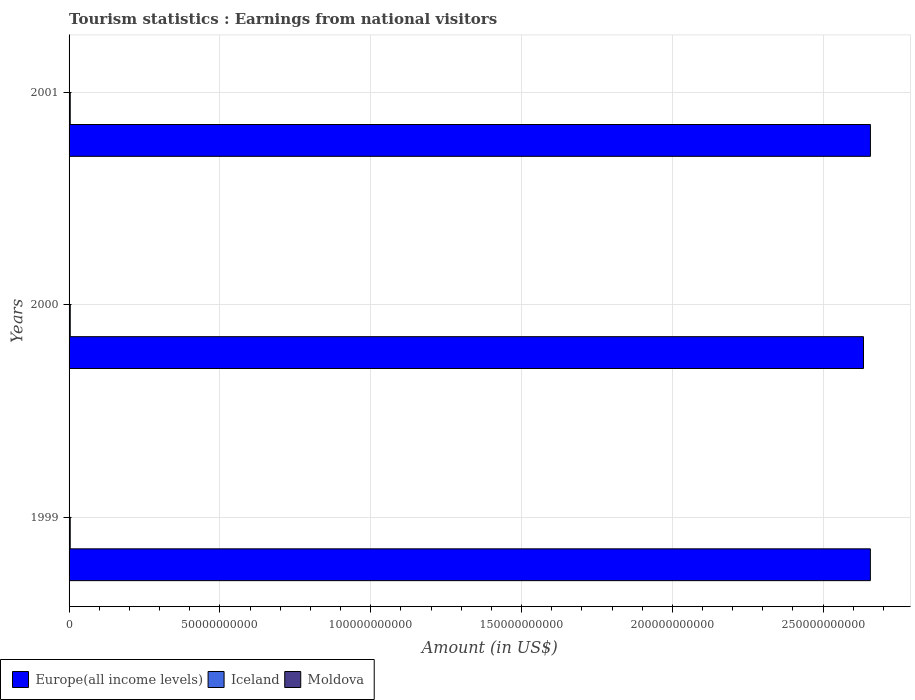How many groups of bars are there?
Offer a terse response. 3. Are the number of bars on each tick of the Y-axis equal?
Offer a terse response. Yes. How many bars are there on the 3rd tick from the top?
Provide a succinct answer. 3. What is the label of the 2nd group of bars from the top?
Offer a very short reply. 2000. In how many cases, is the number of bars for a given year not equal to the number of legend labels?
Offer a very short reply. 0. What is the earnings from national visitors in Iceland in 2001?
Offer a very short reply. 3.83e+08. Across all years, what is the maximum earnings from national visitors in Europe(all income levels)?
Your response must be concise. 2.66e+11. Across all years, what is the minimum earnings from national visitors in Moldova?
Ensure brevity in your answer.  4.90e+07. In which year was the earnings from national visitors in Europe(all income levels) maximum?
Provide a succinct answer. 2001. In which year was the earnings from national visitors in Moldova minimum?
Ensure brevity in your answer.  1999. What is the total earnings from national visitors in Europe(all income levels) in the graph?
Ensure brevity in your answer.  7.95e+11. What is the difference between the earnings from national visitors in Moldova in 2000 and that in 2001?
Offer a very short reply. -1.00e+06. What is the difference between the earnings from national visitors in Iceland in 2001 and the earnings from national visitors in Moldova in 1999?
Keep it short and to the point. 3.34e+08. What is the average earnings from national visitors in Moldova per year?
Your answer should be compact. 5.47e+07. In the year 2000, what is the difference between the earnings from national visitors in Europe(all income levels) and earnings from national visitors in Iceland?
Offer a terse response. 2.63e+11. What is the ratio of the earnings from national visitors in Iceland in 1999 to that in 2000?
Provide a succinct answer. 0.98. What is the difference between the highest and the second highest earnings from national visitors in Europe(all income levels)?
Offer a terse response. 2.21e+07. What is the difference between the highest and the lowest earnings from national visitors in Europe(all income levels)?
Your answer should be very brief. 2.30e+09. Is the sum of the earnings from national visitors in Europe(all income levels) in 2000 and 2001 greater than the maximum earnings from national visitors in Moldova across all years?
Your answer should be compact. Yes. What does the 1st bar from the top in 2001 represents?
Offer a very short reply. Moldova. What does the 2nd bar from the bottom in 1999 represents?
Keep it short and to the point. Iceland. Is it the case that in every year, the sum of the earnings from national visitors in Moldova and earnings from national visitors in Europe(all income levels) is greater than the earnings from national visitors in Iceland?
Provide a succinct answer. Yes. Are all the bars in the graph horizontal?
Ensure brevity in your answer.  Yes. How many years are there in the graph?
Give a very brief answer. 3. What is the difference between two consecutive major ticks on the X-axis?
Give a very brief answer. 5.00e+1. Does the graph contain any zero values?
Give a very brief answer. No. Does the graph contain grids?
Offer a terse response. Yes. Where does the legend appear in the graph?
Provide a short and direct response. Bottom left. What is the title of the graph?
Provide a succinct answer. Tourism statistics : Earnings from national visitors. Does "Turks and Caicos Islands" appear as one of the legend labels in the graph?
Your answer should be compact. No. What is the label or title of the Y-axis?
Ensure brevity in your answer.  Years. What is the Amount (in US$) of Europe(all income levels) in 1999?
Your answer should be compact. 2.66e+11. What is the Amount (in US$) of Iceland in 1999?
Offer a very short reply. 3.80e+08. What is the Amount (in US$) of Moldova in 1999?
Make the answer very short. 4.90e+07. What is the Amount (in US$) of Europe(all income levels) in 2000?
Your answer should be very brief. 2.63e+11. What is the Amount (in US$) of Iceland in 2000?
Ensure brevity in your answer.  3.86e+08. What is the Amount (in US$) of Moldova in 2000?
Your response must be concise. 5.70e+07. What is the Amount (in US$) in Europe(all income levels) in 2001?
Provide a short and direct response. 2.66e+11. What is the Amount (in US$) in Iceland in 2001?
Offer a terse response. 3.83e+08. What is the Amount (in US$) in Moldova in 2001?
Give a very brief answer. 5.80e+07. Across all years, what is the maximum Amount (in US$) in Europe(all income levels)?
Provide a short and direct response. 2.66e+11. Across all years, what is the maximum Amount (in US$) in Iceland?
Ensure brevity in your answer.  3.86e+08. Across all years, what is the maximum Amount (in US$) of Moldova?
Offer a very short reply. 5.80e+07. Across all years, what is the minimum Amount (in US$) in Europe(all income levels)?
Make the answer very short. 2.63e+11. Across all years, what is the minimum Amount (in US$) in Iceland?
Provide a short and direct response. 3.80e+08. Across all years, what is the minimum Amount (in US$) of Moldova?
Make the answer very short. 4.90e+07. What is the total Amount (in US$) of Europe(all income levels) in the graph?
Your answer should be very brief. 7.95e+11. What is the total Amount (in US$) in Iceland in the graph?
Keep it short and to the point. 1.15e+09. What is the total Amount (in US$) in Moldova in the graph?
Provide a succinct answer. 1.64e+08. What is the difference between the Amount (in US$) of Europe(all income levels) in 1999 and that in 2000?
Your answer should be compact. 2.28e+09. What is the difference between the Amount (in US$) of Iceland in 1999 and that in 2000?
Provide a succinct answer. -6.00e+06. What is the difference between the Amount (in US$) of Moldova in 1999 and that in 2000?
Offer a very short reply. -8.00e+06. What is the difference between the Amount (in US$) of Europe(all income levels) in 1999 and that in 2001?
Provide a short and direct response. -2.21e+07. What is the difference between the Amount (in US$) of Moldova in 1999 and that in 2001?
Your answer should be very brief. -9.00e+06. What is the difference between the Amount (in US$) in Europe(all income levels) in 2000 and that in 2001?
Your answer should be very brief. -2.30e+09. What is the difference between the Amount (in US$) of Iceland in 2000 and that in 2001?
Provide a succinct answer. 3.00e+06. What is the difference between the Amount (in US$) of Moldova in 2000 and that in 2001?
Offer a very short reply. -1.00e+06. What is the difference between the Amount (in US$) of Europe(all income levels) in 1999 and the Amount (in US$) of Iceland in 2000?
Your response must be concise. 2.65e+11. What is the difference between the Amount (in US$) of Europe(all income levels) in 1999 and the Amount (in US$) of Moldova in 2000?
Provide a short and direct response. 2.66e+11. What is the difference between the Amount (in US$) in Iceland in 1999 and the Amount (in US$) in Moldova in 2000?
Give a very brief answer. 3.23e+08. What is the difference between the Amount (in US$) in Europe(all income levels) in 1999 and the Amount (in US$) in Iceland in 2001?
Provide a short and direct response. 2.65e+11. What is the difference between the Amount (in US$) of Europe(all income levels) in 1999 and the Amount (in US$) of Moldova in 2001?
Give a very brief answer. 2.66e+11. What is the difference between the Amount (in US$) of Iceland in 1999 and the Amount (in US$) of Moldova in 2001?
Your answer should be very brief. 3.22e+08. What is the difference between the Amount (in US$) in Europe(all income levels) in 2000 and the Amount (in US$) in Iceland in 2001?
Give a very brief answer. 2.63e+11. What is the difference between the Amount (in US$) of Europe(all income levels) in 2000 and the Amount (in US$) of Moldova in 2001?
Keep it short and to the point. 2.63e+11. What is the difference between the Amount (in US$) of Iceland in 2000 and the Amount (in US$) of Moldova in 2001?
Provide a succinct answer. 3.28e+08. What is the average Amount (in US$) in Europe(all income levels) per year?
Offer a very short reply. 2.65e+11. What is the average Amount (in US$) in Iceland per year?
Give a very brief answer. 3.83e+08. What is the average Amount (in US$) of Moldova per year?
Make the answer very short. 5.47e+07. In the year 1999, what is the difference between the Amount (in US$) in Europe(all income levels) and Amount (in US$) in Iceland?
Your response must be concise. 2.65e+11. In the year 1999, what is the difference between the Amount (in US$) in Europe(all income levels) and Amount (in US$) in Moldova?
Make the answer very short. 2.66e+11. In the year 1999, what is the difference between the Amount (in US$) of Iceland and Amount (in US$) of Moldova?
Ensure brevity in your answer.  3.31e+08. In the year 2000, what is the difference between the Amount (in US$) in Europe(all income levels) and Amount (in US$) in Iceland?
Offer a very short reply. 2.63e+11. In the year 2000, what is the difference between the Amount (in US$) of Europe(all income levels) and Amount (in US$) of Moldova?
Offer a terse response. 2.63e+11. In the year 2000, what is the difference between the Amount (in US$) in Iceland and Amount (in US$) in Moldova?
Offer a very short reply. 3.29e+08. In the year 2001, what is the difference between the Amount (in US$) in Europe(all income levels) and Amount (in US$) in Iceland?
Keep it short and to the point. 2.65e+11. In the year 2001, what is the difference between the Amount (in US$) of Europe(all income levels) and Amount (in US$) of Moldova?
Your answer should be compact. 2.66e+11. In the year 2001, what is the difference between the Amount (in US$) of Iceland and Amount (in US$) of Moldova?
Give a very brief answer. 3.25e+08. What is the ratio of the Amount (in US$) in Europe(all income levels) in 1999 to that in 2000?
Make the answer very short. 1.01. What is the ratio of the Amount (in US$) in Iceland in 1999 to that in 2000?
Provide a succinct answer. 0.98. What is the ratio of the Amount (in US$) in Moldova in 1999 to that in 2000?
Your response must be concise. 0.86. What is the ratio of the Amount (in US$) of Iceland in 1999 to that in 2001?
Provide a succinct answer. 0.99. What is the ratio of the Amount (in US$) of Moldova in 1999 to that in 2001?
Offer a terse response. 0.84. What is the ratio of the Amount (in US$) of Iceland in 2000 to that in 2001?
Make the answer very short. 1.01. What is the ratio of the Amount (in US$) of Moldova in 2000 to that in 2001?
Your answer should be very brief. 0.98. What is the difference between the highest and the second highest Amount (in US$) of Europe(all income levels)?
Your answer should be compact. 2.21e+07. What is the difference between the highest and the lowest Amount (in US$) in Europe(all income levels)?
Make the answer very short. 2.30e+09. What is the difference between the highest and the lowest Amount (in US$) of Moldova?
Keep it short and to the point. 9.00e+06. 